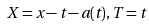<formula> <loc_0><loc_0><loc_500><loc_500>X = x - t - a ( t ) , T = t</formula> 